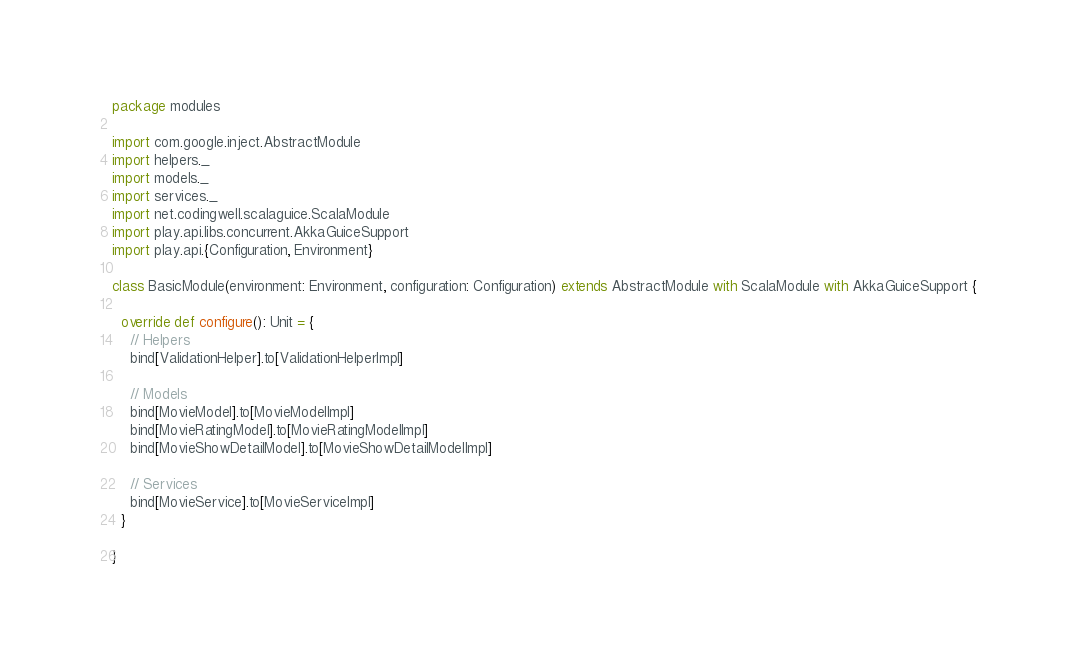<code> <loc_0><loc_0><loc_500><loc_500><_Scala_>package modules

import com.google.inject.AbstractModule
import helpers._
import models._
import services._
import net.codingwell.scalaguice.ScalaModule
import play.api.libs.concurrent.AkkaGuiceSupport
import play.api.{Configuration, Environment}

class BasicModule(environment: Environment, configuration: Configuration) extends AbstractModule with ScalaModule with AkkaGuiceSupport {

  override def configure(): Unit = {
    // Helpers
    bind[ValidationHelper].to[ValidationHelperImpl]

    // Models
    bind[MovieModel].to[MovieModelImpl]
    bind[MovieRatingModel].to[MovieRatingModelImpl]
    bind[MovieShowDetailModel].to[MovieShowDetailModelImpl]

    // Services
    bind[MovieService].to[MovieServiceImpl]
  }

}
</code> 